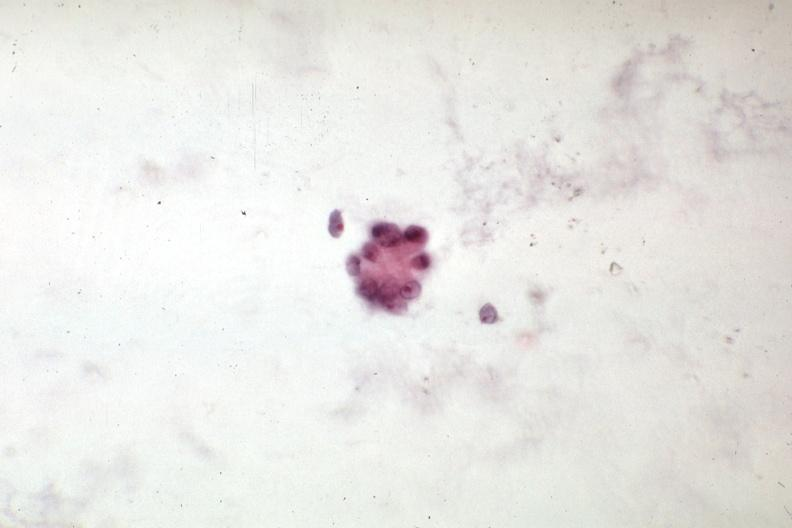s carcinoma present?
Answer the question using a single word or phrase. Yes 